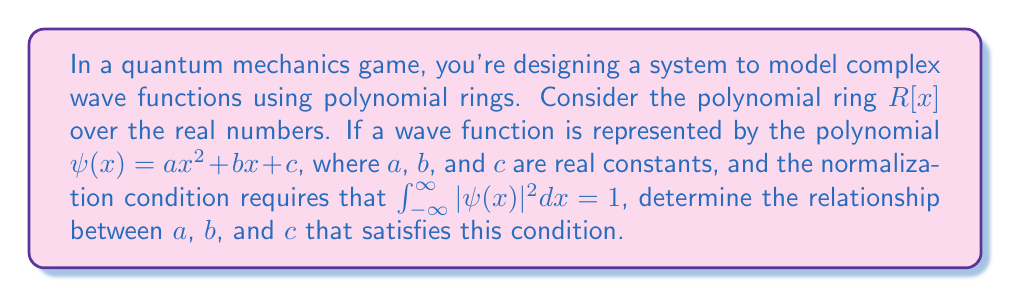What is the answer to this math problem? To solve this problem, we need to follow these steps:

1) First, we need to calculate $|\psi(x)|^2$:
   $$|\psi(x)|^2 = (ax^2 + bx + c)(ax^2 + bx + c) = a^2x^4 + 2abx^3 + (2ac+b^2)x^2 + 2bcx + c^2$$

2) Now, we need to integrate this from $-\infty$ to $\infty$:
   $$\int_{-\infty}^{\infty} (a^2x^4 + 2abx^3 + (2ac+b^2)x^2 + 2bcx + c^2) dx = 1$$

3) Most terms in this integral will evaluate to zero over the infinite range, except for even-powered terms:
   $$\int_{-\infty}^{\infty} a^2x^4 dx + \int_{-\infty}^{\infty} (2ac+b^2)x^2 dx + \int_{-\infty}^{\infty} c^2 dx = 1$$

4) We can evaluate these integrals:
   $$a^2 \cdot \frac{2}{5}x^5 \Big|_{-\infty}^{\infty} + (2ac+b^2) \cdot \frac{1}{3}x^3 \Big|_{-\infty}^{\infty} + c^2x \Big|_{-\infty}^{\infty} = 1$$

5) The $x^5$ and $x^3$ terms will diverge to infinity unless their coefficients are zero. Therefore:
   $$a^2 = 0 \text{ and } 2ac+b^2 = 0$$

6) From $a^2 = 0$, we can conclude that $a = 0$.

7) Substituting this into $2ac+b^2 = 0$, we get $b^2 = 0$, so $b = 0$.

8) Now our equation simplifies to:
   $$c^2x \Big|_{-\infty}^{\infty} = 1$$

9) For this to be true, we must have $c^2 = 0$, which is impossible if we want a non-zero wave function.

This result shows that it's impossible to normalize a quadratic polynomial wave function over an infinite domain. In practice, wave functions in quantum mechanics often involve exponential terms to ensure they can be normalized.
Answer: The relationship $a = b = 0$ and $c \neq 0$ is required, but this leads to a constant function that cannot be normalized over an infinite domain. Therefore, a quadratic polynomial in $R[x]$ cannot represent a normalizable wave function over an infinite domain. 